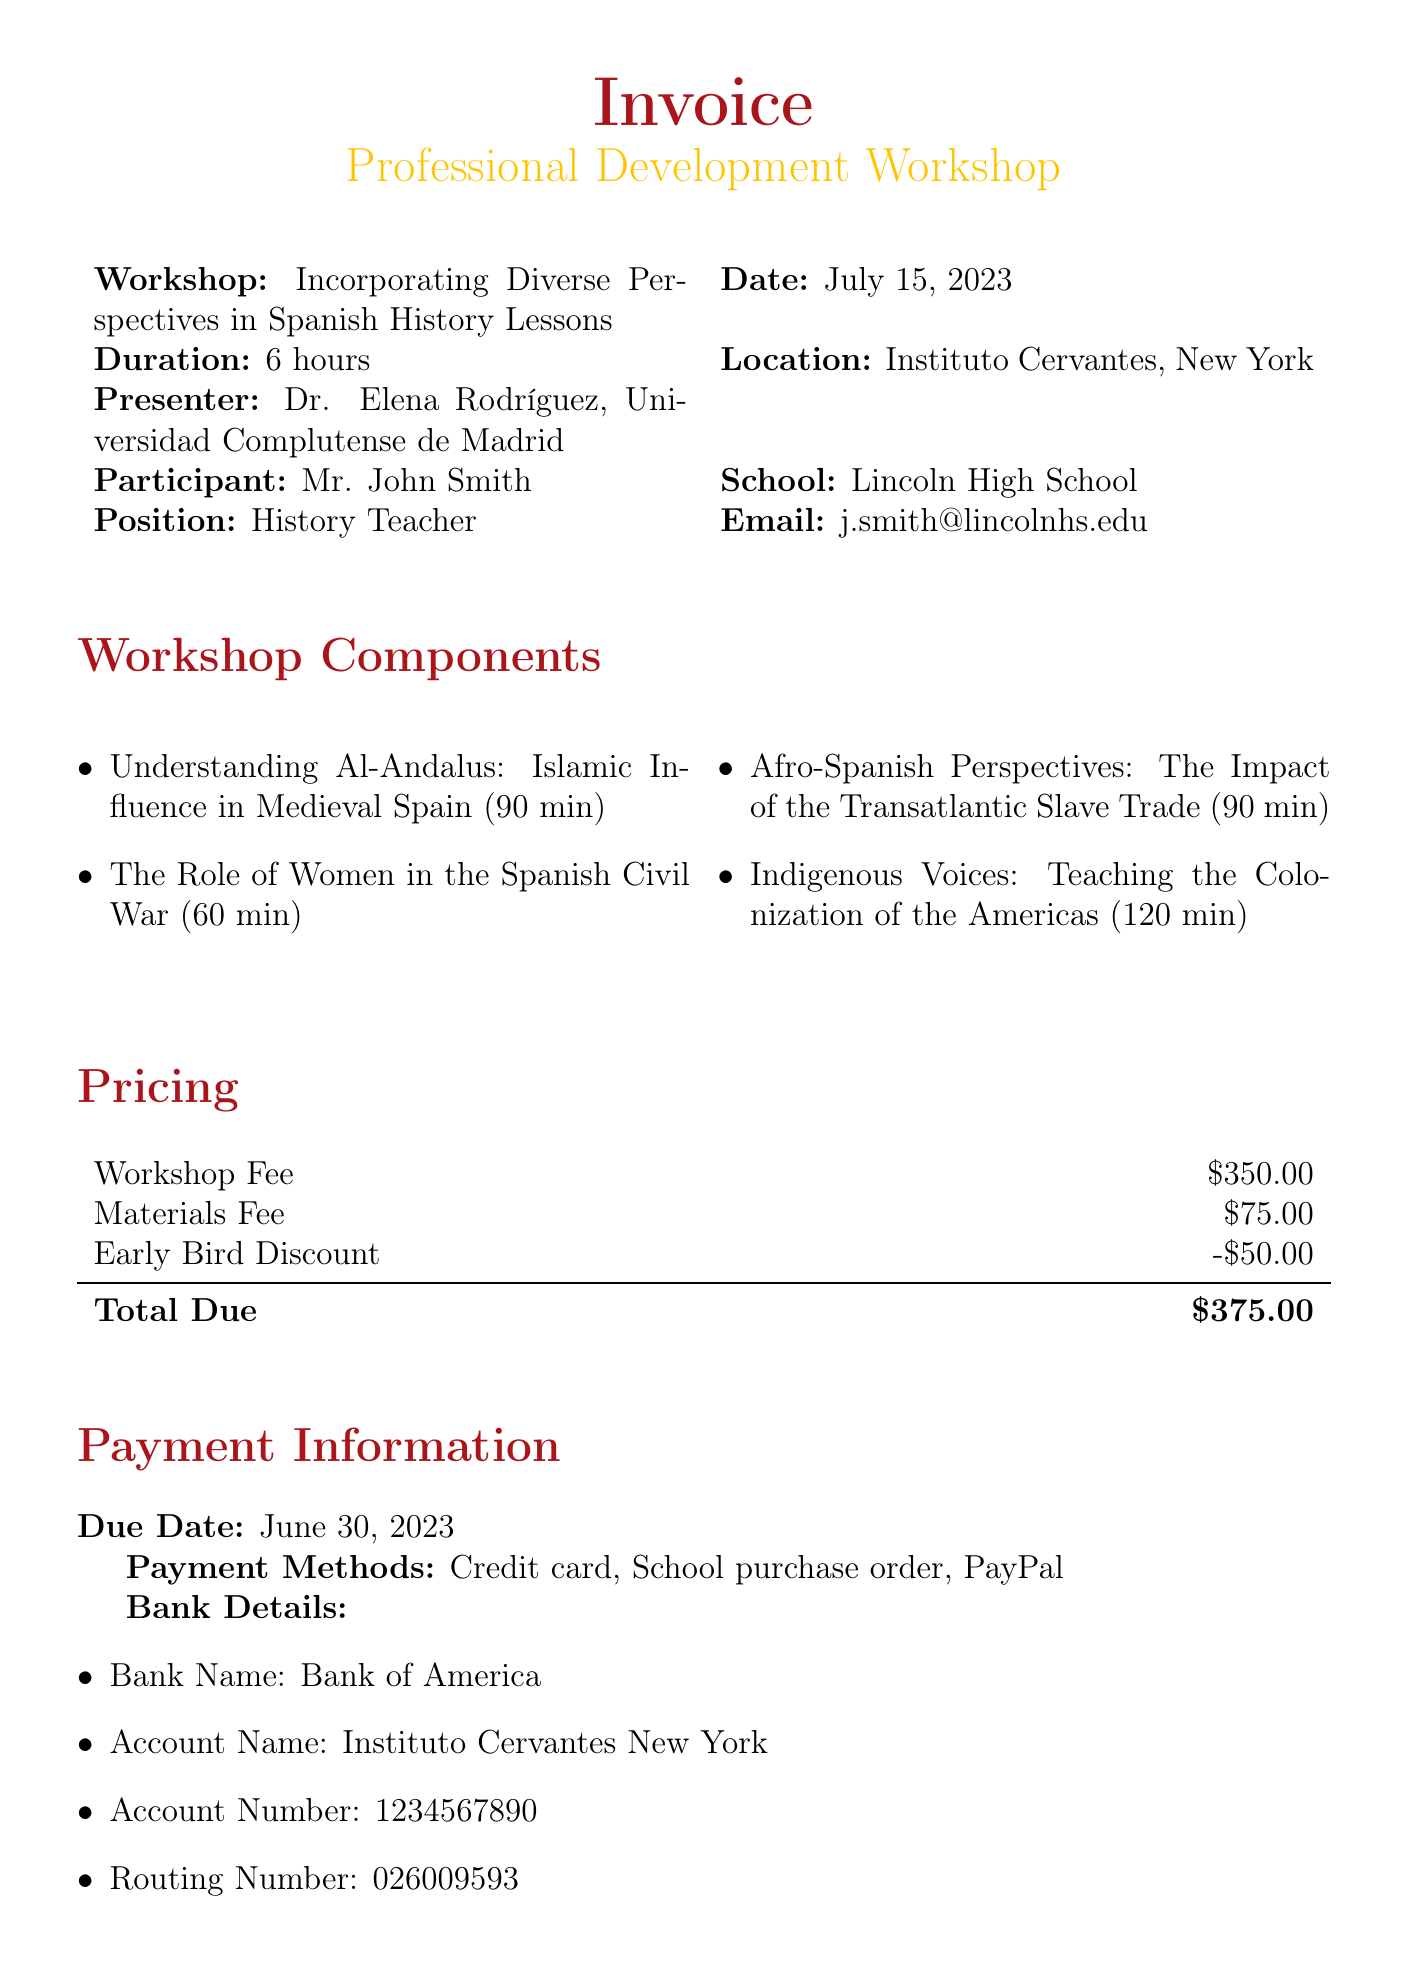what is the title of the workshop? The title of the workshop is provided in the workshop details section.
Answer: Incorporating Diverse Perspectives in Spanish History Lessons who is the presenter of the workshop? The presenter's name and title can be found in the workshop details.
Answer: Dr. Elena Rodríguez what is the total fee due for the workshop? The total fee is calculated after applying the early bird discount to the workshop and materials fee.
Answer: $375 when is the payment due date? The payment due date is explicitly mentioned in the payment information section.
Answer: June 30, 2023 how long is the workshop? The duration of the workshop is specified in the workshop details.
Answer: 6 hours what materials are used for the topic "Understanding Al-Andalus"? The specific materials for each workshop component are listed under workshop components.
Answer: Textbook: 'Islamic Spain: 711-1492' by Richard Fletcher which payment methods are accepted for the workshop? Accepted payment methods are listed in the payment information section.
Answer: Credit card, School purchase order, PayPal what is one cultural sensitivity note mentioned in the document? The cultural sensitivity notes are listed at the end of the document; one can be retrieved from there.
Answer: Emphasize the importance of using inclusive language when discussing different ethnic and religious groups in Spanish history what additional resource costs $49? Additional resources are outlined in a section; the cost of each is mentioned alongside the title.
Answer: Spain's Roma Community: A Forgotten History 